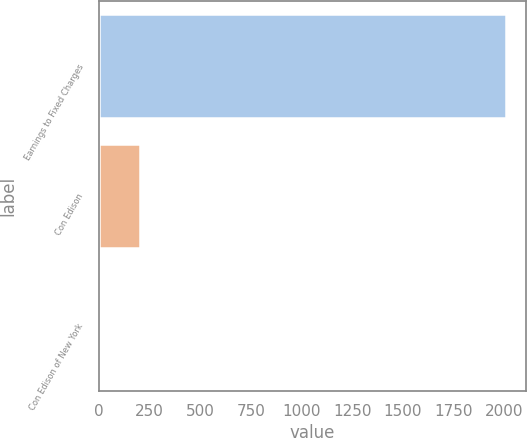Convert chart to OTSL. <chart><loc_0><loc_0><loc_500><loc_500><bar_chart><fcel>Earnings to Fixed Charges<fcel>Con Edison<fcel>Con Edison of New York<nl><fcel>2008<fcel>203.77<fcel>3.3<nl></chart> 